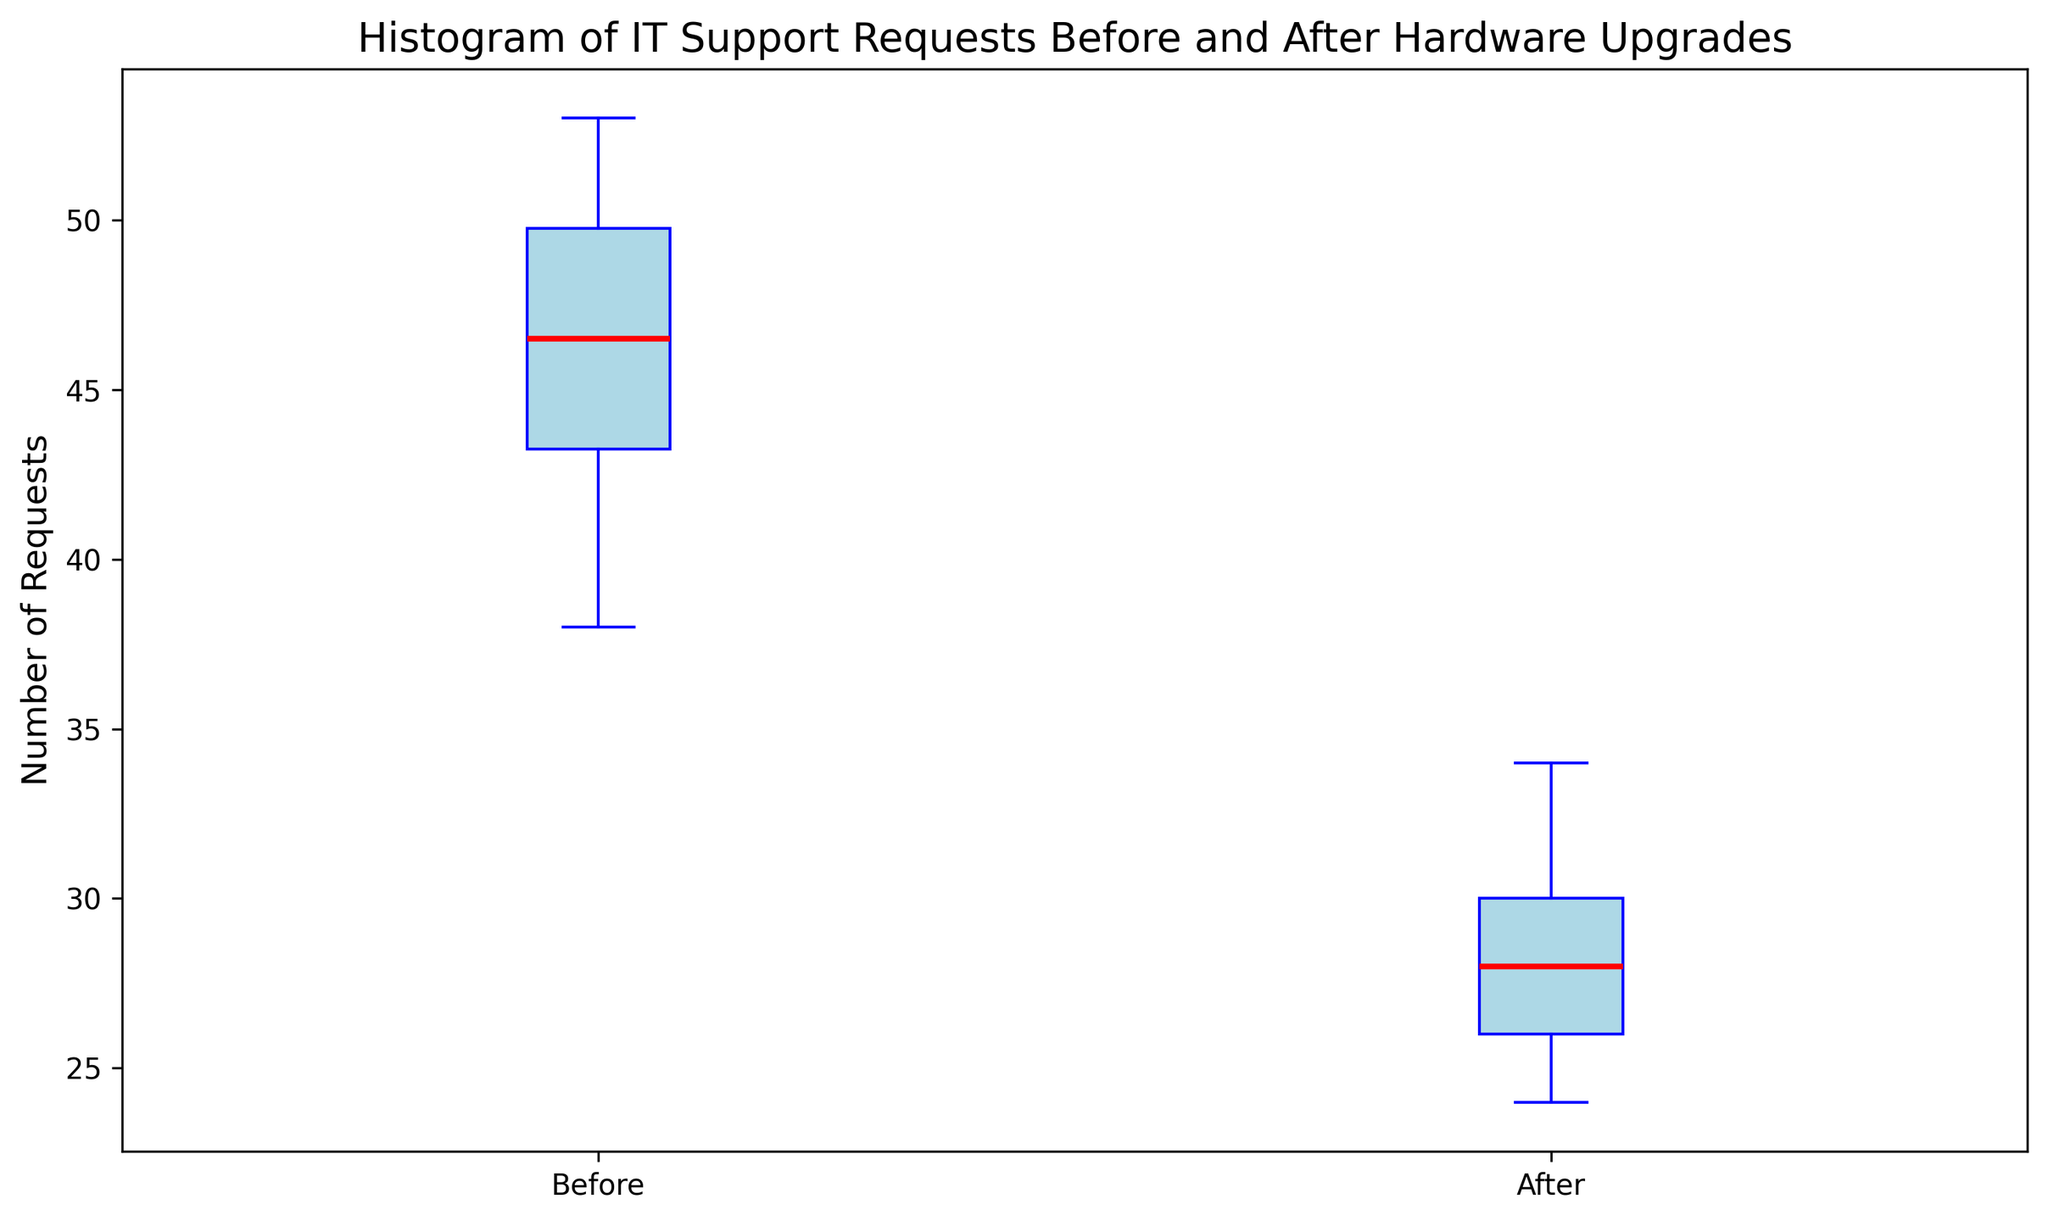What's the median value of IT support requests before and after the hardware upgrades? The median for the "Before" category can be found by looking at the red line within the box of the first box plot, while the median for the "After" category can be found by looking at the red line within the box of the second box plot.
Answer: Before: 46, After: 28 Which category shows a higher range of IT support requests? The range can be determined by looking at the distance between the minimum and maximum values (whiskers) in each box plot. The "Before" category has a longer whisker span compared to the "After" category.
Answer: Before What is the interquartile range (IQR) for IT support requests before and after the hardware upgrades? The IQR is the difference between the third quartile (top of the box) and the first quartile (bottom of the box). For the "Before" category, it is the height of the blue box on the left. For the "After" category, it is the height of the blue box on the right.
Answer: Before: 8, After: 5 Did the median number of IT support requests increase or decrease after the hardware upgrades? By comparing the positions of the red lines (medians) on the "Before" and "After" box plots, one can see that the red line for "After" is lower. This indicates a decrease.
Answer: Decrease Which category has more outliers based on the visual representation of the box plot? Outliers are represented by yellow circles outside the whiskers. Compare the number of yellow circles in each category.
Answer: Before Is there more variability in the IT support requests before or after the hardware upgrades? Variability can be assessed by the length of the whiskers and the overall height of the box plot. The "Before" category shows a wider spread with longer whiskers and a taller box.
Answer: Before What is the maximum number of IT support requests recorded before the hardware upgrades? The maximum value is indicated by the topmost point of the upper whisker on the "Before" box plot.
Answer: 53 What visual cue indicates the median number of IT support requests? The median is indicated by the red line within each box of the box plot.
Answer: Red line Did the minimum number of IT support requests change before and after the hardware upgrades? The minimum value is indicated by the bottommost point of the lower whisker. Compare the positions of the lower whiskers for both categories.
Answer: Yes, it decreased 